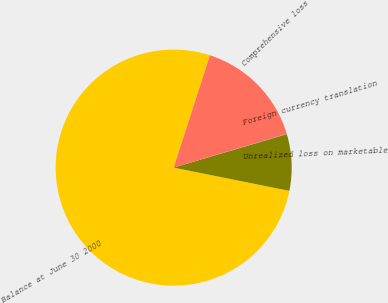Convert chart. <chart><loc_0><loc_0><loc_500><loc_500><pie_chart><fcel>Balance at June 30 2000<fcel>Unrealized loss on marketable<fcel>Foreign currency translation<fcel>Comprehensive loss<nl><fcel>76.81%<fcel>7.73%<fcel>0.05%<fcel>15.4%<nl></chart> 